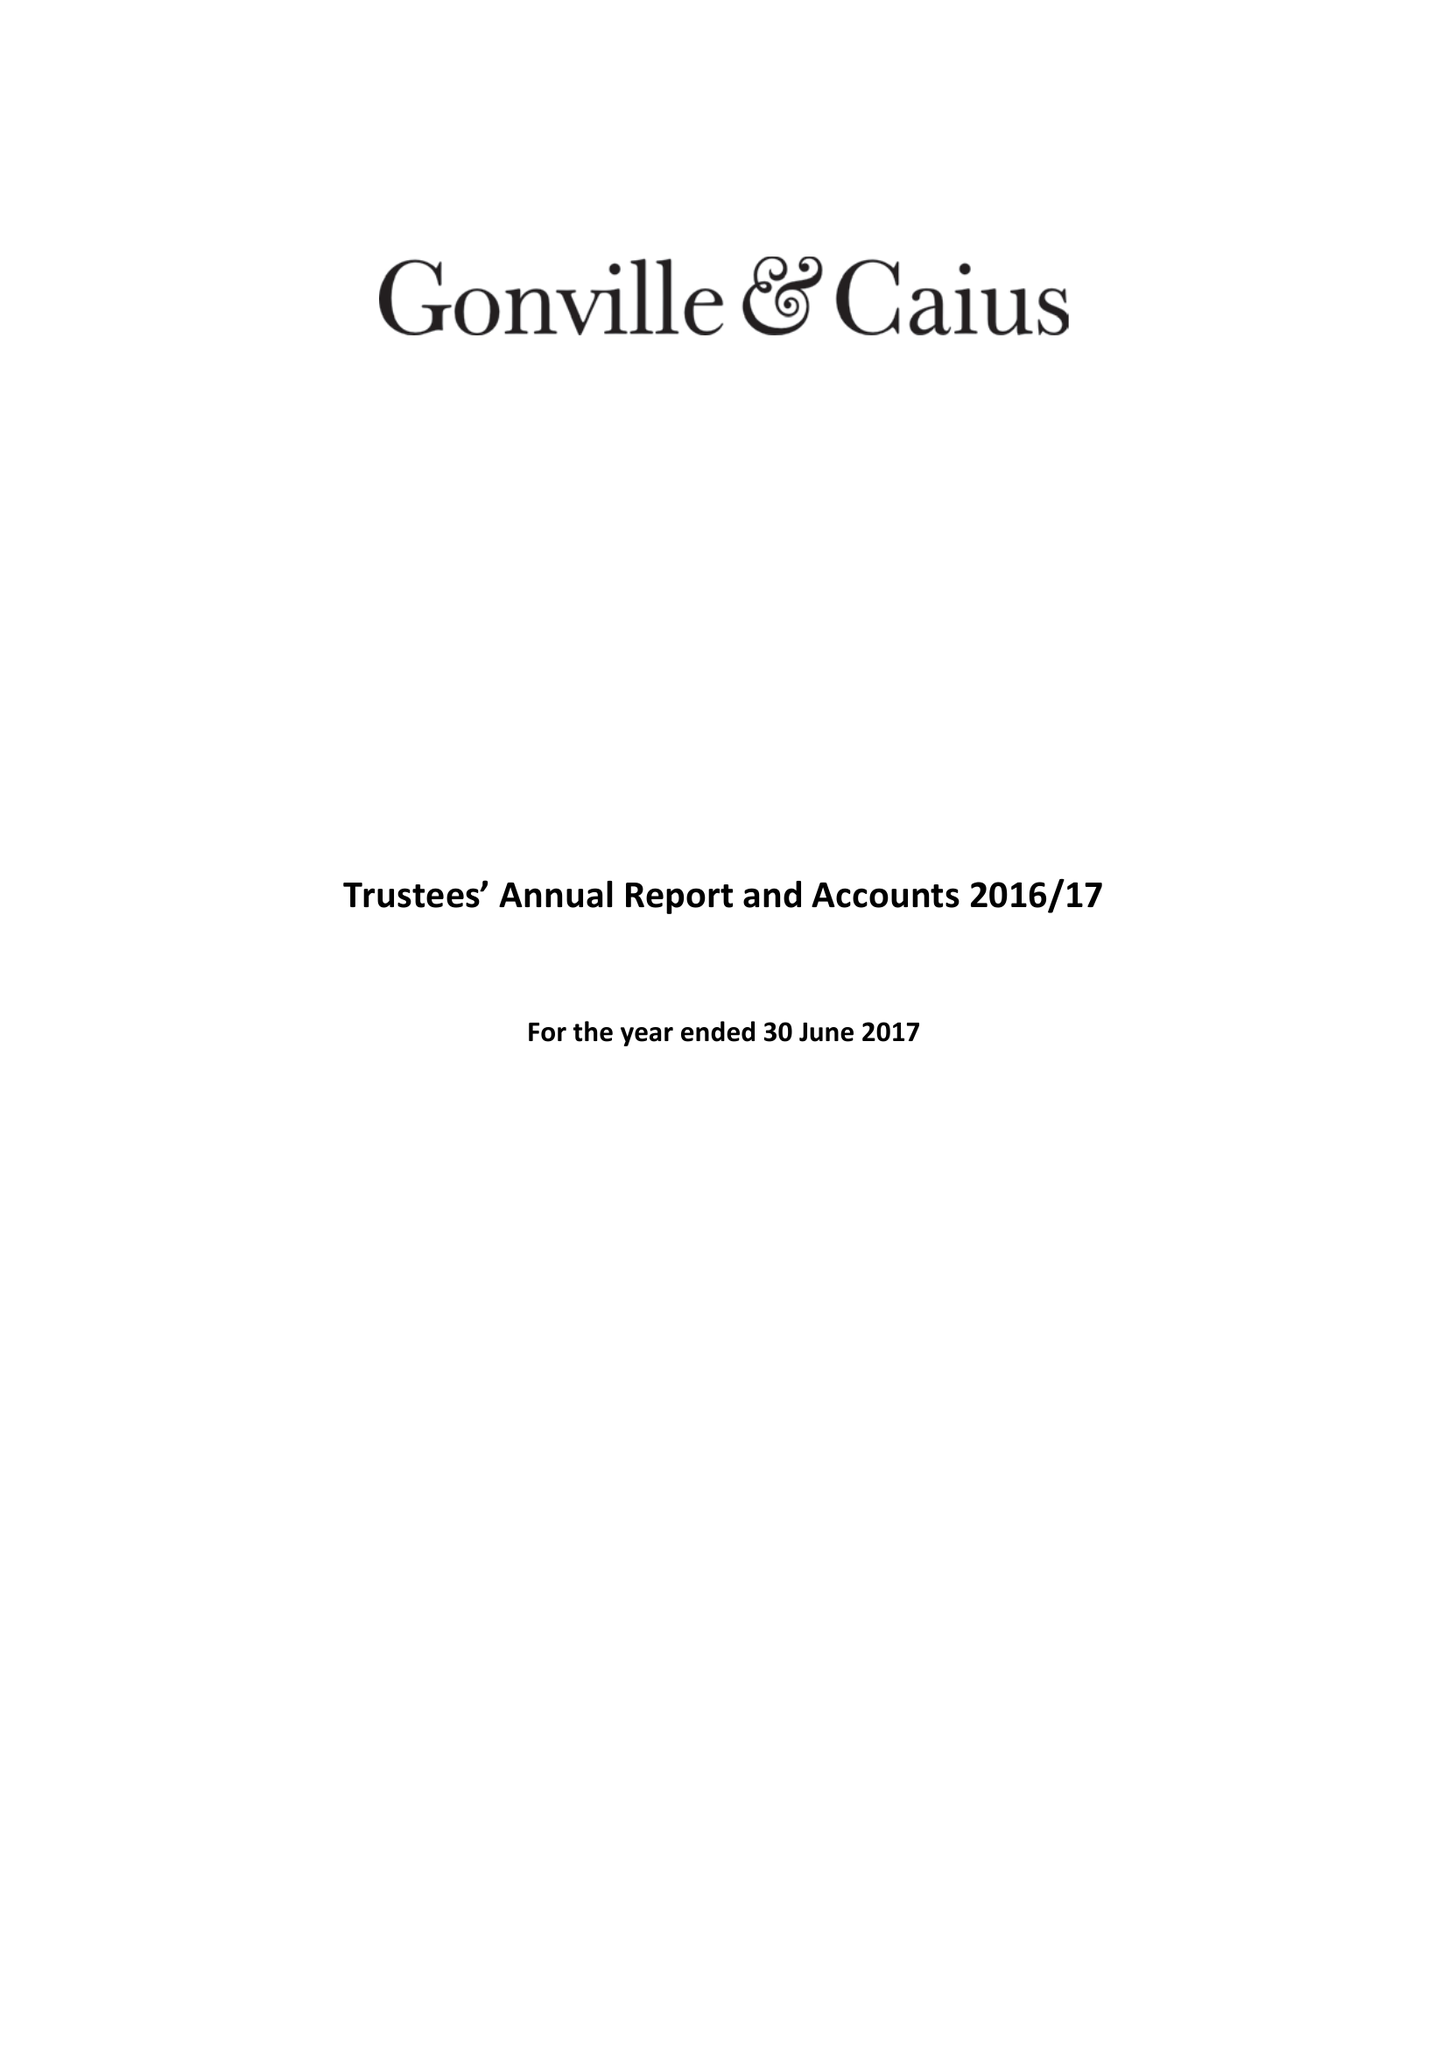What is the value for the address__street_line?
Answer the question using a single word or phrase. TRINITY STREET 